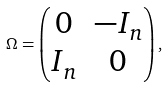<formula> <loc_0><loc_0><loc_500><loc_500>\Omega = \left ( \begin{matrix} 0 & - I _ { n } \\ I _ { n } & 0 \end{matrix} \right ) ,</formula> 